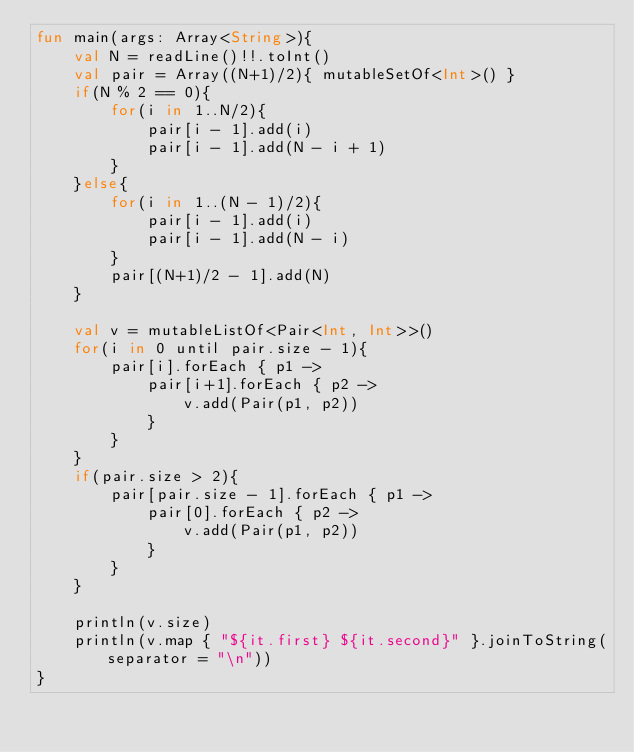Convert code to text. <code><loc_0><loc_0><loc_500><loc_500><_Kotlin_>fun main(args: Array<String>){
    val N = readLine()!!.toInt()
    val pair = Array((N+1)/2){ mutableSetOf<Int>() }
    if(N % 2 == 0){
        for(i in 1..N/2){
            pair[i - 1].add(i)
            pair[i - 1].add(N - i + 1)
        }
    }else{
        for(i in 1..(N - 1)/2){
            pair[i - 1].add(i)
            pair[i - 1].add(N - i)
        }
        pair[(N+1)/2 - 1].add(N)
    }

    val v = mutableListOf<Pair<Int, Int>>()
    for(i in 0 until pair.size - 1){
        pair[i].forEach { p1 ->
            pair[i+1].forEach { p2 ->
                v.add(Pair(p1, p2))
            }
        }
    }
    if(pair.size > 2){
        pair[pair.size - 1].forEach { p1 ->
            pair[0].forEach { p2 ->
                v.add(Pair(p1, p2))
            }
        }
    }

    println(v.size)
    println(v.map { "${it.first} ${it.second}" }.joinToString(separator = "\n"))
}</code> 